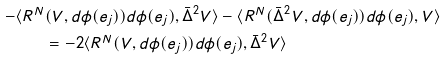<formula> <loc_0><loc_0><loc_500><loc_500>- \langle R ^ { N } & ( V , d \phi ( e _ { j } ) ) d \phi ( e _ { j } ) , \bar { \Delta } ^ { 2 } V \rangle - \langle R ^ { N } ( \bar { \Delta } ^ { 2 } V , d \phi ( e _ { j } ) ) d \phi ( e _ { j } ) , V \rangle \\ & = - 2 \langle R ^ { N } ( V , d \phi ( e _ { j } ) ) d \phi ( e _ { j } ) , \bar { \Delta } ^ { 2 } V \rangle</formula> 